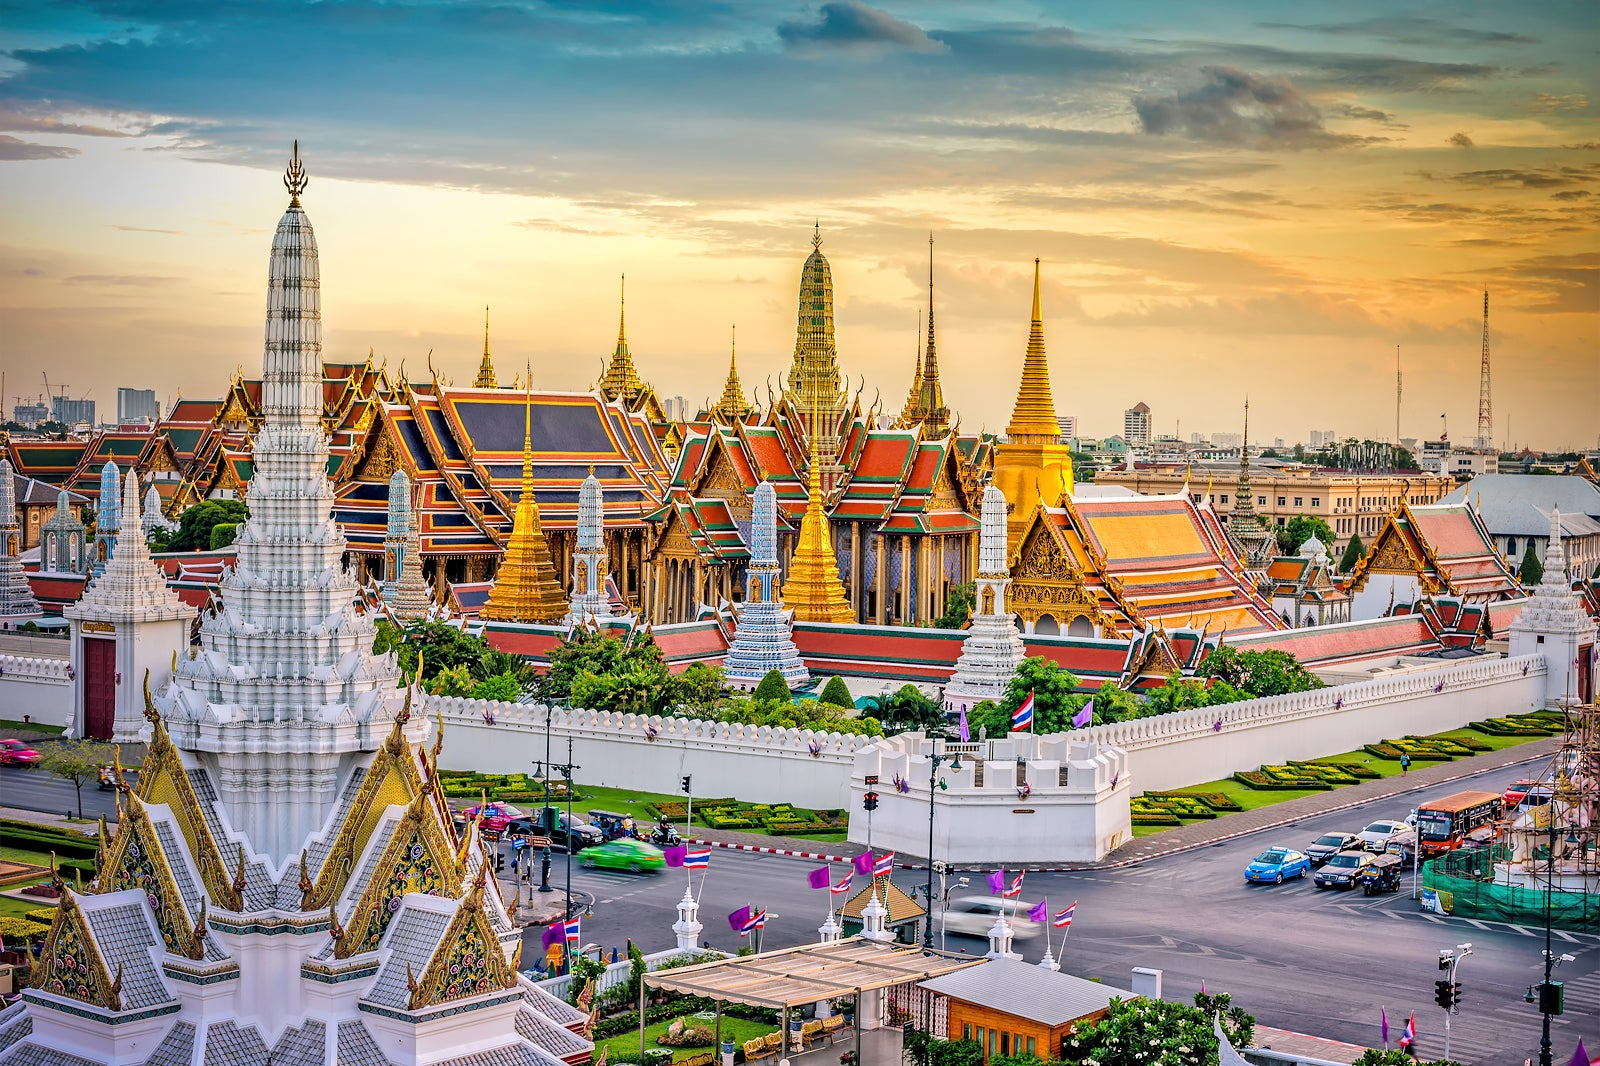Describe the following image. The image showcases the awe-inspiring grandeur of the Grand Palace in Bangkok, Thailand. This impressive complex comprises a multitude of buildings that exhibit traditional Thai architecture. Highlighted by vibrant red and gold roofs, the structures are adorned with intricately designed spires and pagodas, demonstrating an opulent aesthetic. Encircling the palace is a pristine white wall, punctuated by a gated entrance, providing a sense of enclosed royalty. Captured from an elevated viewpoint, the photograph offers a sweeping panoramic view of the palace with the bustling city skyline extending beyond, beneath a sky speckled with clouds. This depiction beautifully captures the landmark's architectural splendor, its cultural significance, and its elevated stature within Bangkok's urban landscape. 